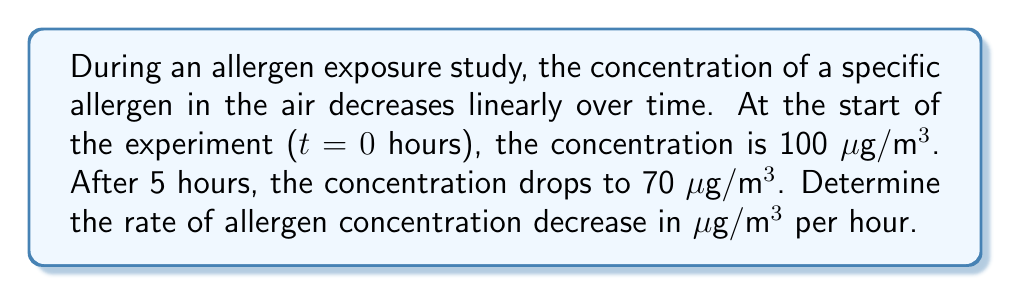Provide a solution to this math problem. To solve this problem, we'll use the linear equation formula:

$$y = mx + b$$

Where:
$y$ is the allergen concentration
$m$ is the rate of change (slope)
$x$ is the time
$b$ is the initial concentration

We know two points:
1. At $t = 0$, concentration = 100 μg/m³
2. At $t = 5$, concentration = 70 μg/m³

Let's find the slope (rate of change):

$$m = \frac{y_2 - y_1}{x_2 - x_1} = \frac{70 - 100}{5 - 0} = \frac{-30}{5} = -6$$

The negative sign indicates a decrease in concentration.

Therefore, the rate of allergen concentration decrease is 6 μg/m³ per hour.

To verify:
Initial concentration: 100 μg/m³
After 5 hours: $100 + (-6 \times 5) = 100 - 30 = 70$ μg/m³

This matches our given information, confirming the calculation.
Answer: -6 μg/m³/hour 